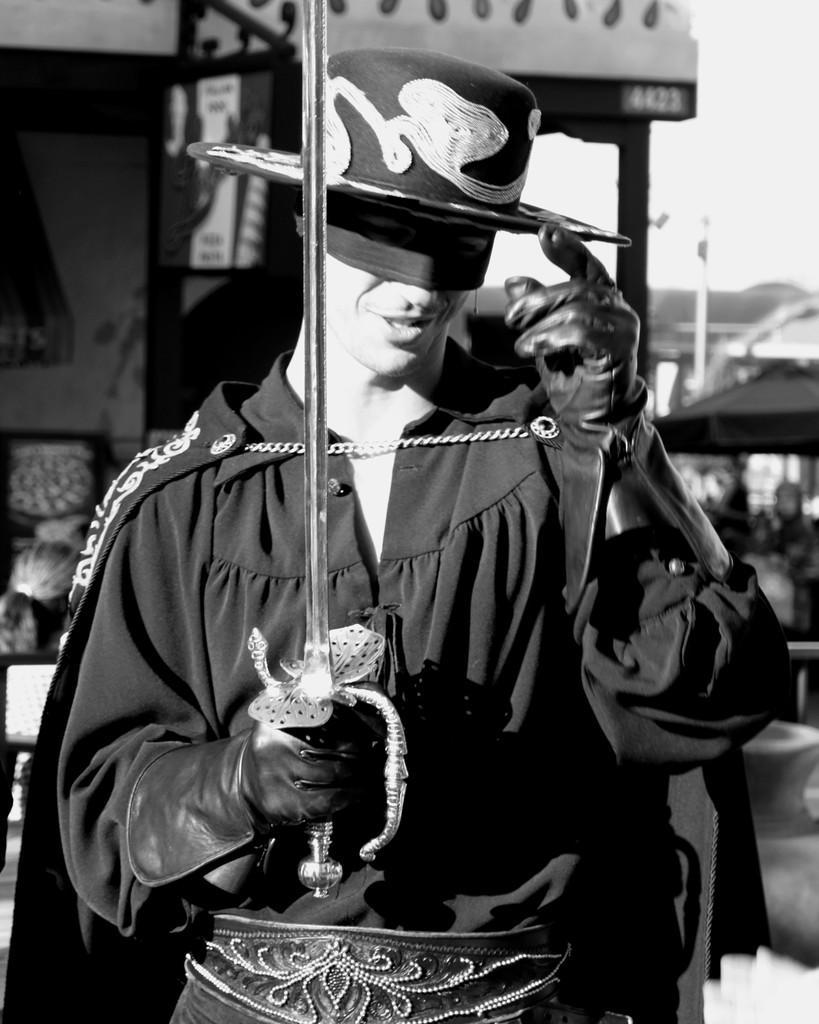Could you give a brief overview of what you see in this image? In this image a man is standing holding a sword wearing black dress, cape, hat, mask and glove. In the background there are buildings, people. 